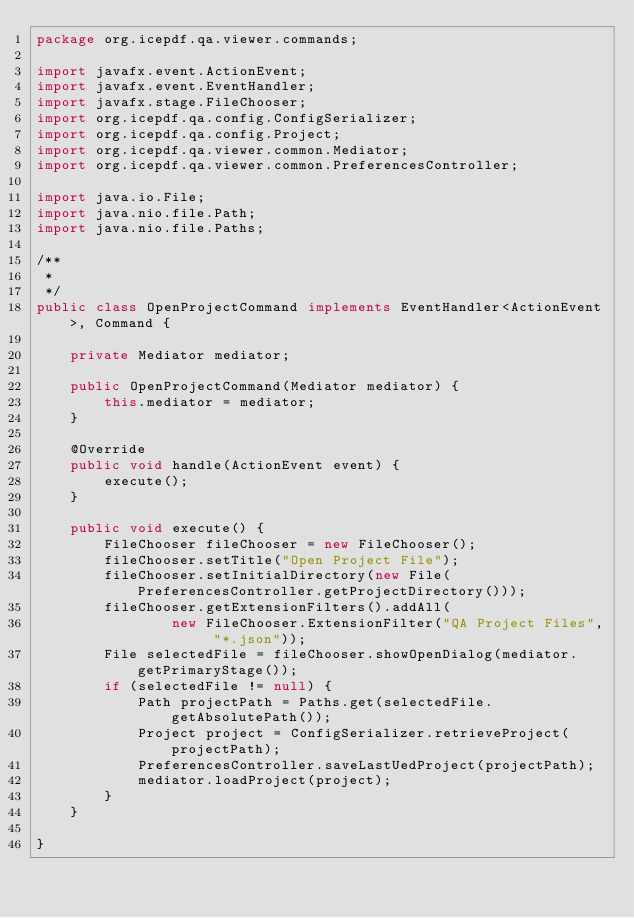<code> <loc_0><loc_0><loc_500><loc_500><_Java_>package org.icepdf.qa.viewer.commands;

import javafx.event.ActionEvent;
import javafx.event.EventHandler;
import javafx.stage.FileChooser;
import org.icepdf.qa.config.ConfigSerializer;
import org.icepdf.qa.config.Project;
import org.icepdf.qa.viewer.common.Mediator;
import org.icepdf.qa.viewer.common.PreferencesController;

import java.io.File;
import java.nio.file.Path;
import java.nio.file.Paths;

/**
 *
 */
public class OpenProjectCommand implements EventHandler<ActionEvent>, Command {

    private Mediator mediator;

    public OpenProjectCommand(Mediator mediator) {
        this.mediator = mediator;
    }

    @Override
    public void handle(ActionEvent event) {
        execute();
    }

    public void execute() {
        FileChooser fileChooser = new FileChooser();
        fileChooser.setTitle("Open Project File");
        fileChooser.setInitialDirectory(new File(PreferencesController.getProjectDirectory()));
        fileChooser.getExtensionFilters().addAll(
                new FileChooser.ExtensionFilter("QA Project Files", "*.json"));
        File selectedFile = fileChooser.showOpenDialog(mediator.getPrimaryStage());
        if (selectedFile != null) {
            Path projectPath = Paths.get(selectedFile.getAbsolutePath());
            Project project = ConfigSerializer.retrieveProject(projectPath);
            PreferencesController.saveLastUedProject(projectPath);
            mediator.loadProject(project);
        }
    }

}</code> 